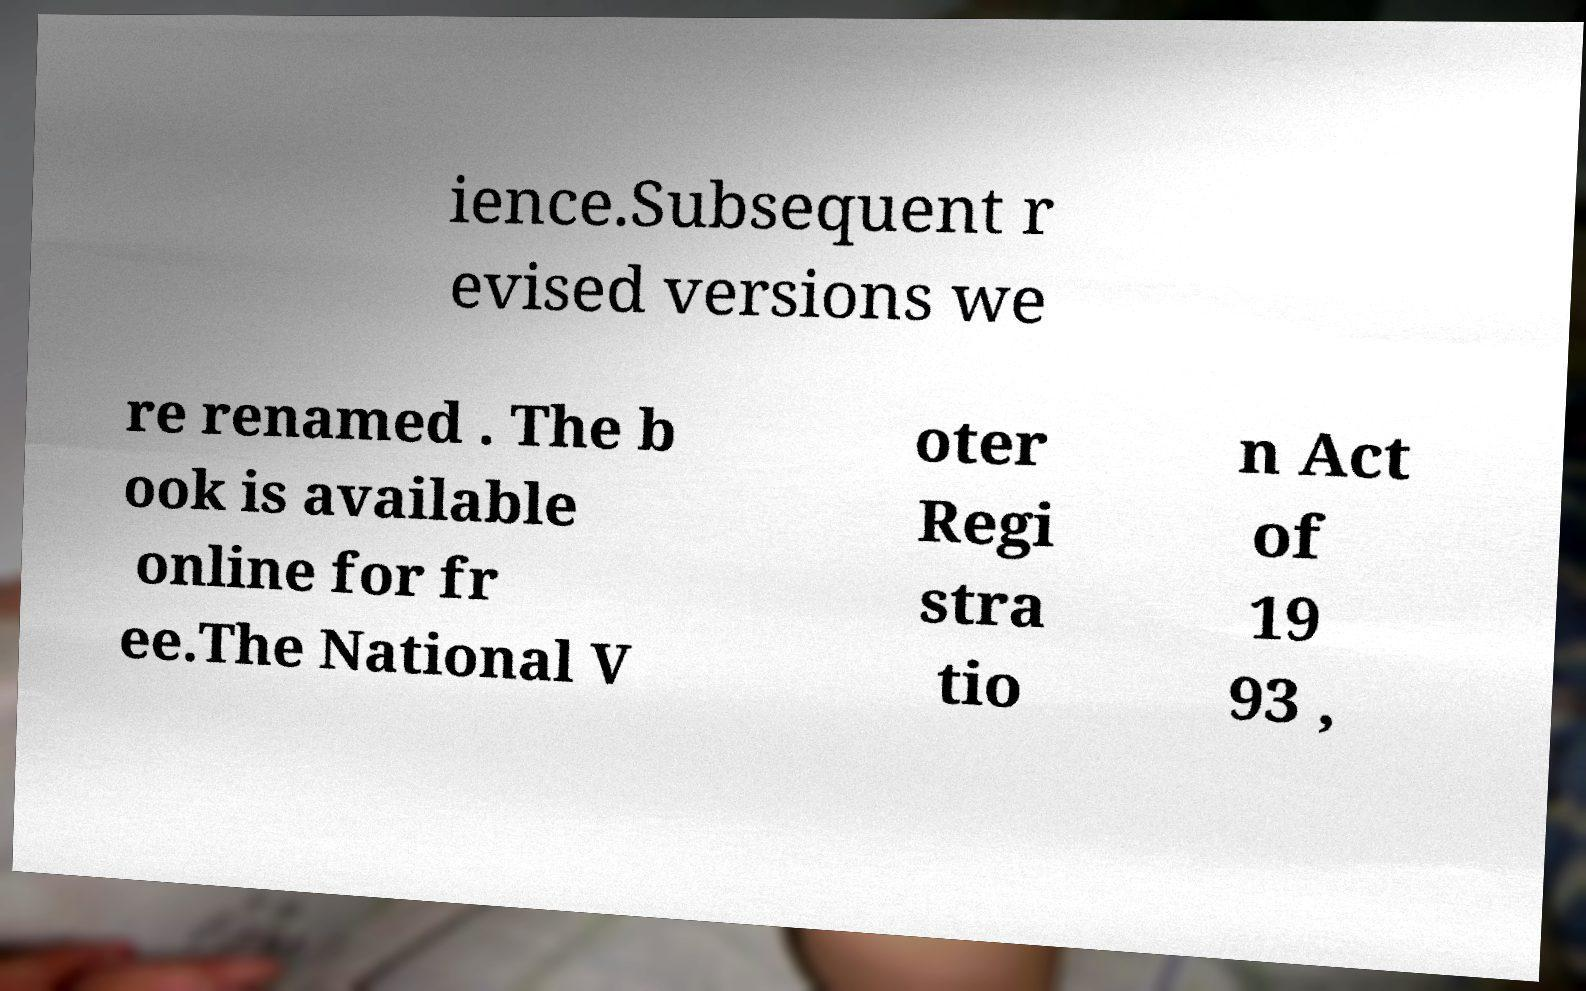What messages or text are displayed in this image? I need them in a readable, typed format. ience.Subsequent r evised versions we re renamed . The b ook is available online for fr ee.The National V oter Regi stra tio n Act of 19 93 , 